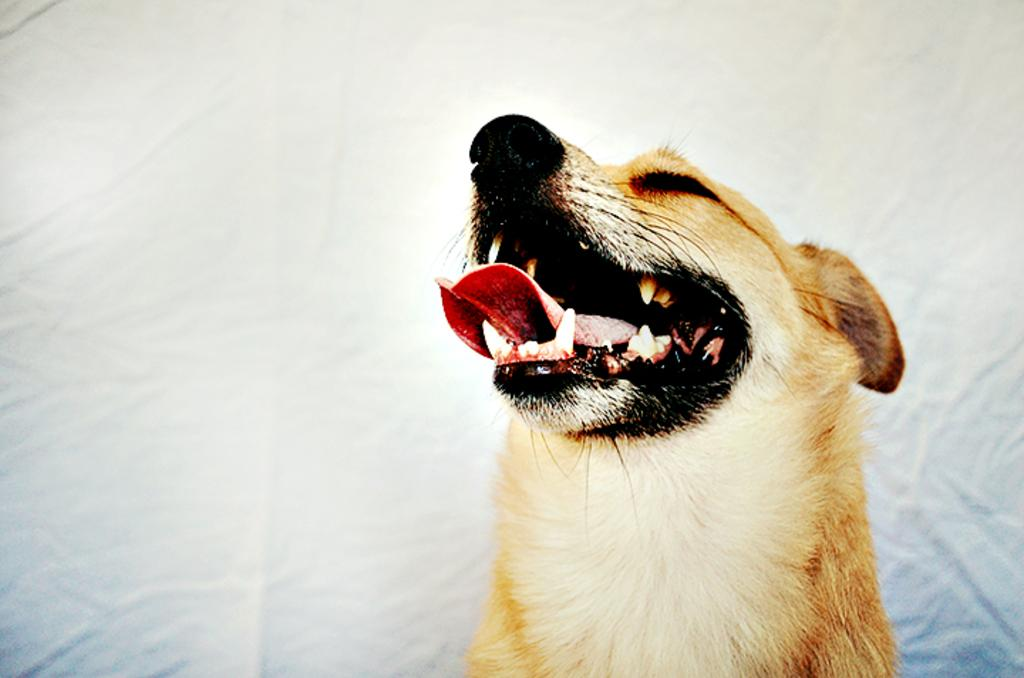What type of animal is present in the image? There is a dog in the image. What can be seen in the background of the image? There is a curtain in the background of the image. What industry is depicted in the image? There is no industry present in the image; it features a dog and a curtain. How does the dog say good-bye in the image? Dogs do not say good-bye, as they do not have the ability to speak or use human language. 